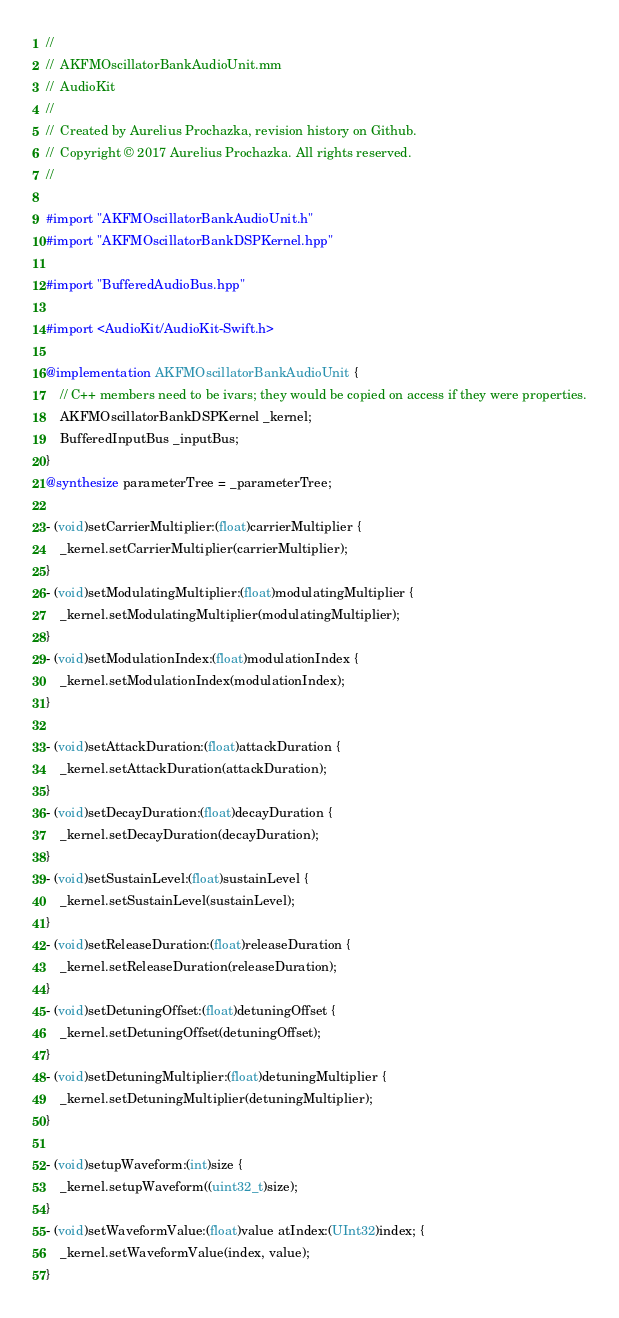<code> <loc_0><loc_0><loc_500><loc_500><_ObjectiveC_>//
//  AKFMOscillatorBankAudioUnit.mm
//  AudioKit
//
//  Created by Aurelius Prochazka, revision history on Github.
//  Copyright © 2017 Aurelius Prochazka. All rights reserved.
//

#import "AKFMOscillatorBankAudioUnit.h"
#import "AKFMOscillatorBankDSPKernel.hpp"

#import "BufferedAudioBus.hpp"

#import <AudioKit/AudioKit-Swift.h>

@implementation AKFMOscillatorBankAudioUnit {
    // C++ members need to be ivars; they would be copied on access if they were properties.
    AKFMOscillatorBankDSPKernel _kernel;
    BufferedInputBus _inputBus;
}
@synthesize parameterTree = _parameterTree;

- (void)setCarrierMultiplier:(float)carrierMultiplier {
    _kernel.setCarrierMultiplier(carrierMultiplier);
}
- (void)setModulatingMultiplier:(float)modulatingMultiplier {
    _kernel.setModulatingMultiplier(modulatingMultiplier);
}
- (void)setModulationIndex:(float)modulationIndex {
    _kernel.setModulationIndex(modulationIndex);
}

- (void)setAttackDuration:(float)attackDuration {
    _kernel.setAttackDuration(attackDuration);
}
- (void)setDecayDuration:(float)decayDuration {
    _kernel.setDecayDuration(decayDuration);
}
- (void)setSustainLevel:(float)sustainLevel {
    _kernel.setSustainLevel(sustainLevel);
}
- (void)setReleaseDuration:(float)releaseDuration {
    _kernel.setReleaseDuration(releaseDuration);
}
- (void)setDetuningOffset:(float)detuningOffset {
    _kernel.setDetuningOffset(detuningOffset);
}
- (void)setDetuningMultiplier:(float)detuningMultiplier {
    _kernel.setDetuningMultiplier(detuningMultiplier);
}

- (void)setupWaveform:(int)size {
    _kernel.setupWaveform((uint32_t)size);
}
- (void)setWaveformValue:(float)value atIndex:(UInt32)index; {
    _kernel.setWaveformValue(index, value);
}
</code> 